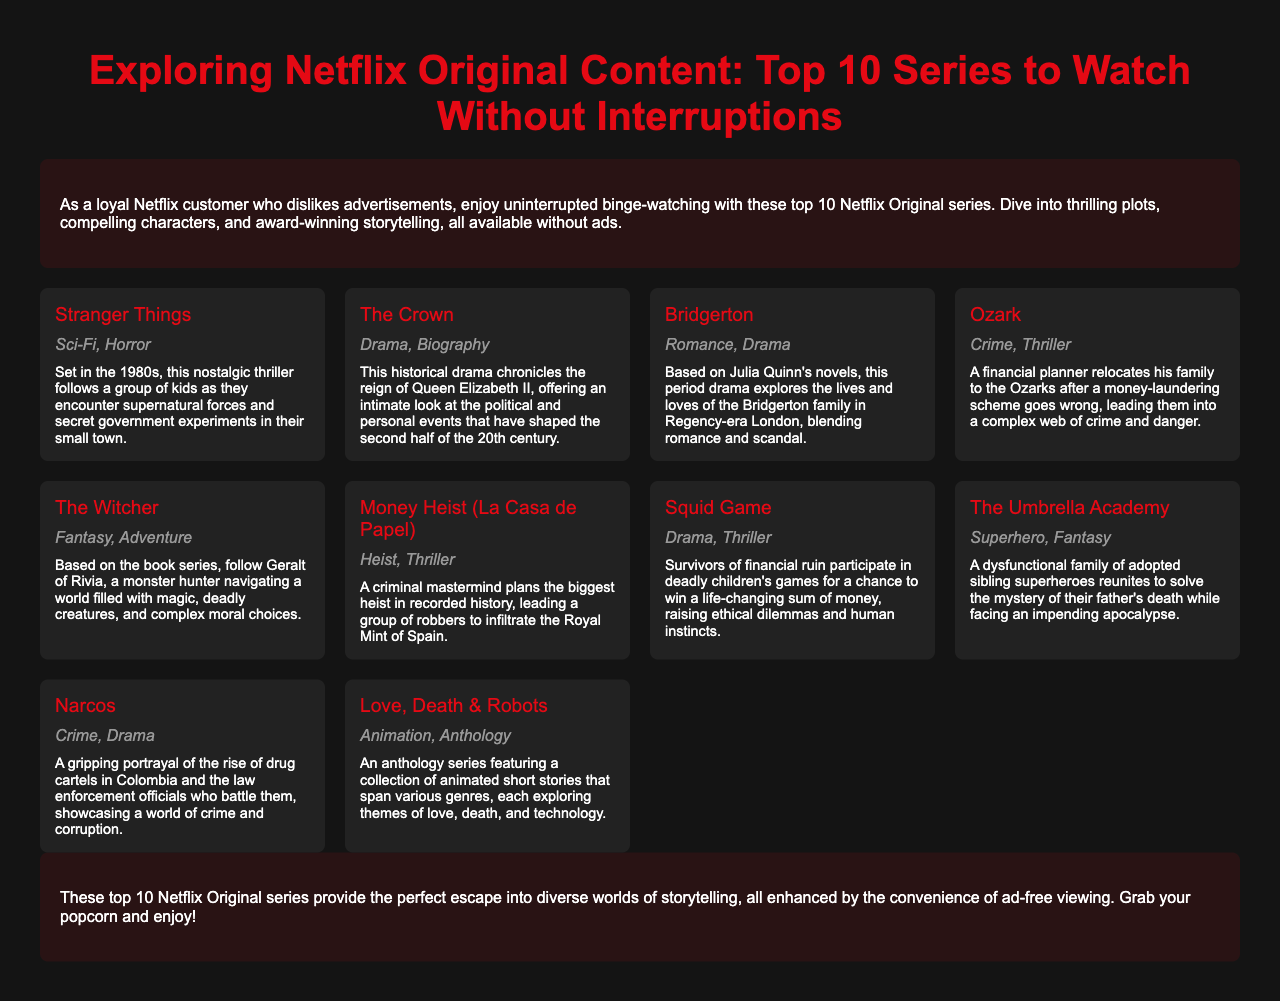What is the title of the brochure? The title of the brochure is presented prominently at the top of the document.
Answer: Exploring Netflix Original Content: Top 10 Series to Watch Without Interruptions How many series are listed in the brochure? Counting the individual series cards provides a total of series included in the document.
Answer: 10 What genre is "The Crown"? Each series card includes the genre associated with the series, notably highlighting the genre for "The Crown".
Answer: Drama, Biography Which series features a monster hunter? The series description explains the main character's role in the story, identifying a specific type of character.
Answer: The Witcher What type of series is "Love, Death & Robots"? The genre details of "Love, Death & Robots" are provided in the series card, highlighting its classification.
Answer: Animation, Anthology Which series involves a heist in Spain? The description outlines the central plot of specific series, making it possible to identify the series related to a heist.
Answer: Money Heist (La Casa de Papel) What characterizes the viewing experience of the listed series? The introductory section emphasizes an important aspect of watching these series for the audience.
Answer: Uninterrupted binge-watching Which series is set in Regency-era London? The series card for this specific title includes the setting details that describe its time period.
Answer: Bridgerton What is the main theme explored in "Squid Game"? The description mentions key themes present within the story, indicating the primary focus of the series narrative.
Answer: Ethical dilemmas and human instincts 